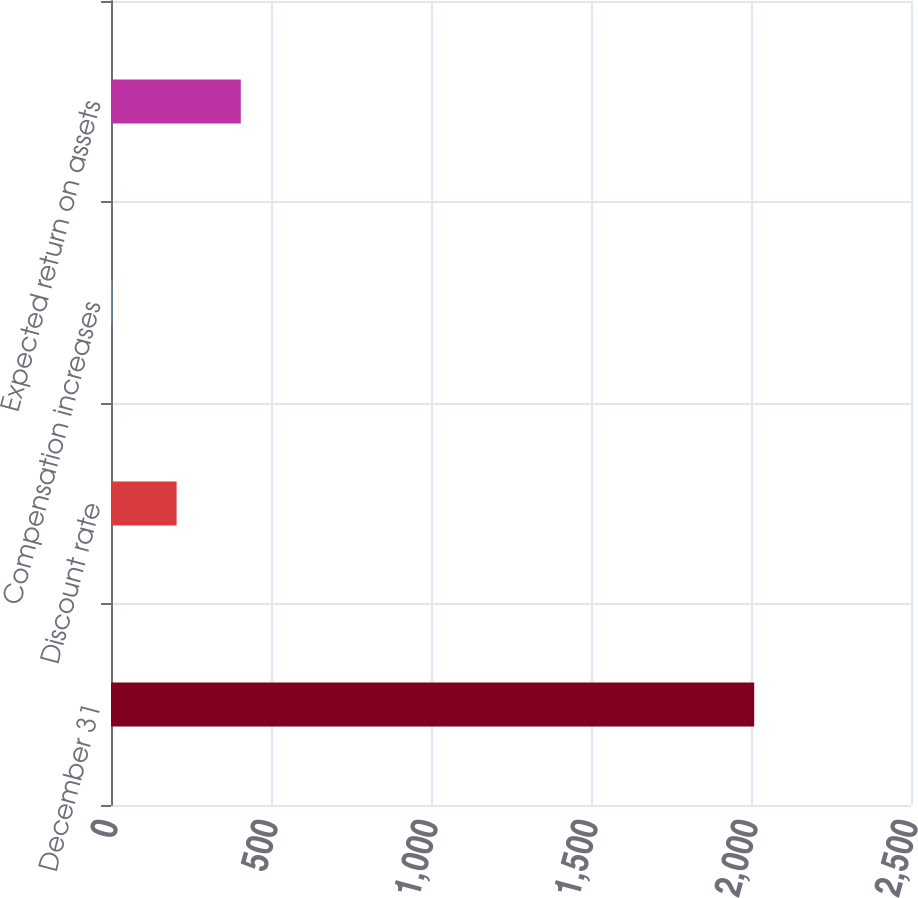Convert chart. <chart><loc_0><loc_0><loc_500><loc_500><bar_chart><fcel>December 31<fcel>Discount rate<fcel>Compensation increases<fcel>Expected return on assets<nl><fcel>2010<fcel>205<fcel>4.44<fcel>405.56<nl></chart> 